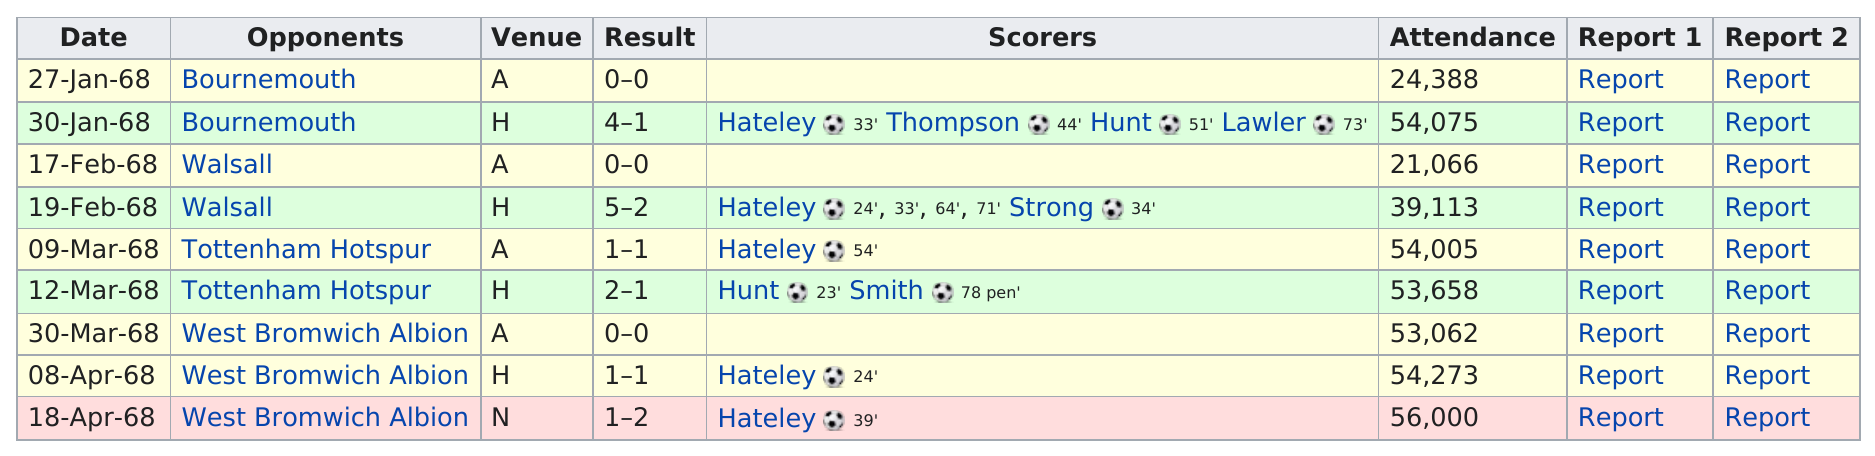Indicate a few pertinent items in this graphic. During the FA Cup, a total of 2 players scored at least 2 goals. Hateley scored 8 goals in total. The largest difference in goals scored in any game was 3 goals. It has been 10 days since the last two games were played. On January 30, 1968, the number of people in attendance was 54,075. 